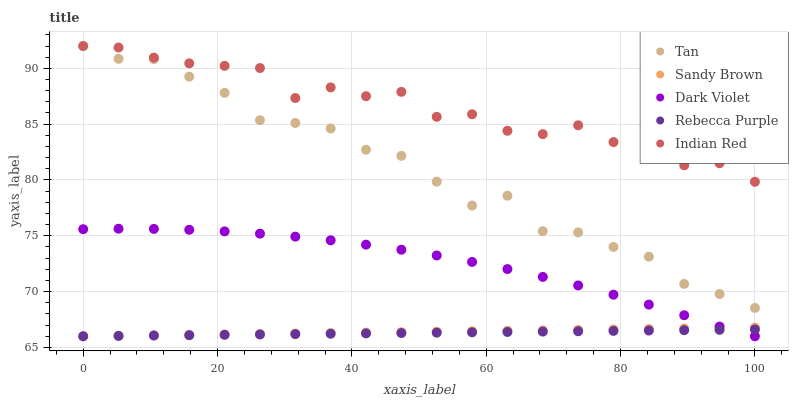Does Rebecca Purple have the minimum area under the curve?
Answer yes or no. Yes. Does Indian Red have the maximum area under the curve?
Answer yes or no. Yes. Does Tan have the minimum area under the curve?
Answer yes or no. No. Does Tan have the maximum area under the curve?
Answer yes or no. No. Is Sandy Brown the smoothest?
Answer yes or no. Yes. Is Indian Red the roughest?
Answer yes or no. Yes. Is Tan the smoothest?
Answer yes or no. No. Is Tan the roughest?
Answer yes or no. No. Does Sandy Brown have the lowest value?
Answer yes or no. Yes. Does Tan have the lowest value?
Answer yes or no. No. Does Tan have the highest value?
Answer yes or no. Yes. Does Sandy Brown have the highest value?
Answer yes or no. No. Is Dark Violet less than Tan?
Answer yes or no. Yes. Is Indian Red greater than Rebecca Purple?
Answer yes or no. Yes. Does Rebecca Purple intersect Sandy Brown?
Answer yes or no. Yes. Is Rebecca Purple less than Sandy Brown?
Answer yes or no. No. Is Rebecca Purple greater than Sandy Brown?
Answer yes or no. No. Does Dark Violet intersect Tan?
Answer yes or no. No. 